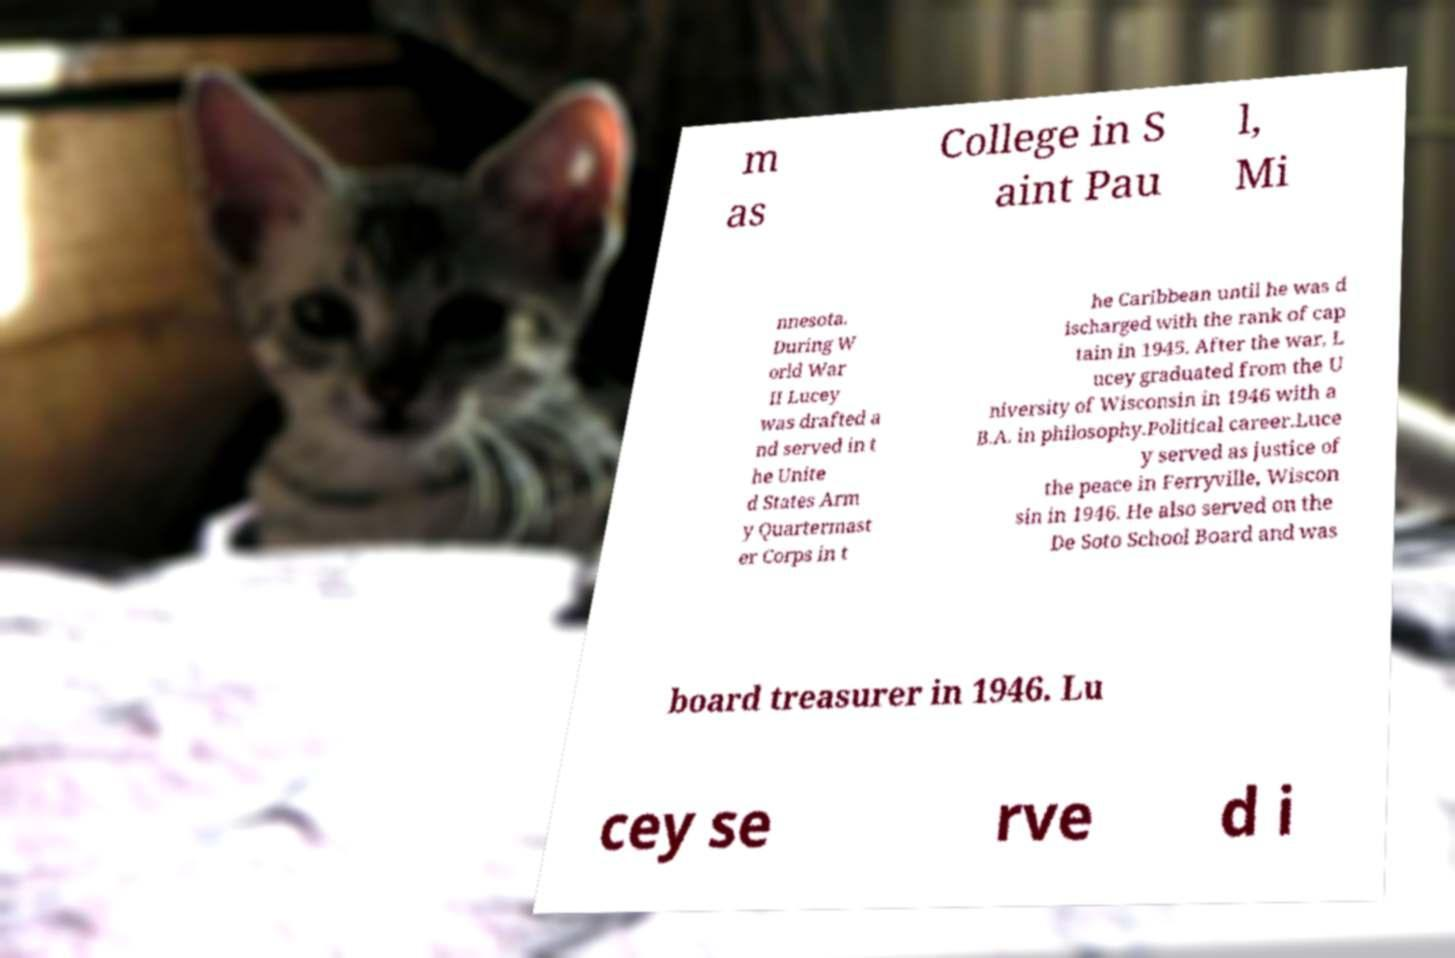Please identify and transcribe the text found in this image. m as College in S aint Pau l, Mi nnesota. During W orld War II Lucey was drafted a nd served in t he Unite d States Arm y Quartermast er Corps in t he Caribbean until he was d ischarged with the rank of cap tain in 1945. After the war, L ucey graduated from the U niversity of Wisconsin in 1946 with a B.A. in philosophy.Political career.Luce y served as justice of the peace in Ferryville, Wiscon sin in 1946. He also served on the De Soto School Board and was board treasurer in 1946. Lu cey se rve d i 